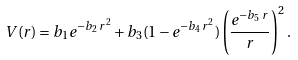<formula> <loc_0><loc_0><loc_500><loc_500>V ( r ) = b _ { 1 } e ^ { - b _ { 2 } \, r ^ { 2 } } + b _ { 3 } ( 1 - e ^ { - b _ { 4 } \, r ^ { 2 } } ) \left ( \frac { e ^ { - b _ { 5 } \, r } } { r } \right ) ^ { 2 } .</formula> 